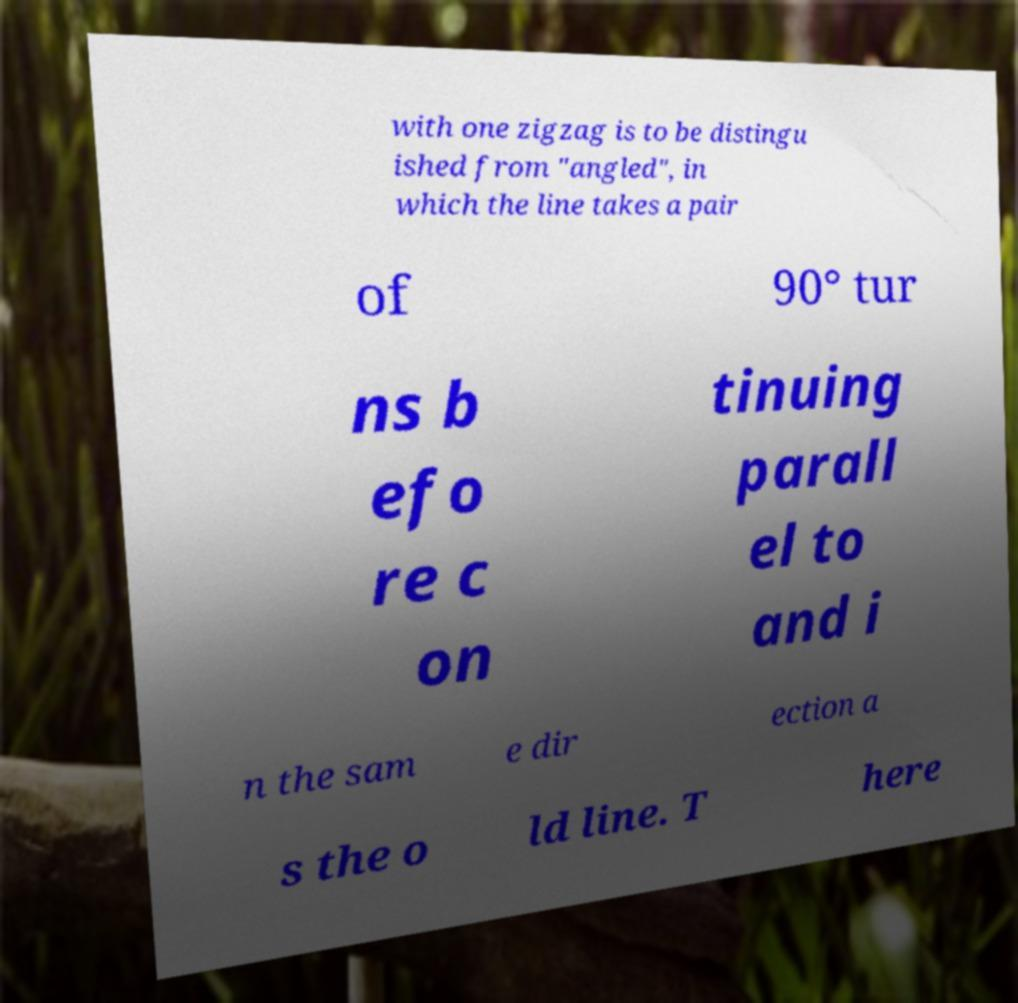I need the written content from this picture converted into text. Can you do that? with one zigzag is to be distingu ished from "angled", in which the line takes a pair of 90° tur ns b efo re c on tinuing parall el to and i n the sam e dir ection a s the o ld line. T here 